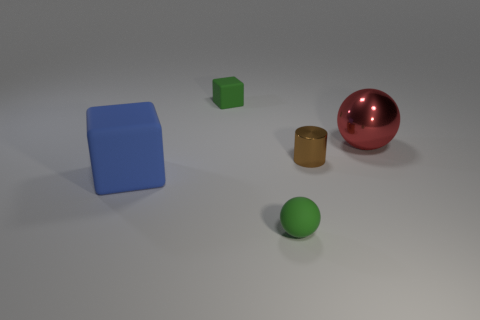There is a rubber thing behind the red sphere; does it have the same color as the tiny sphere?
Provide a succinct answer. Yes. Is the color of the tiny rubber ball the same as the object that is behind the large red shiny thing?
Ensure brevity in your answer.  Yes. Are there any other things that have the same color as the matte ball?
Make the answer very short. Yes. What material is the small green object that is the same shape as the big metallic thing?
Your answer should be very brief. Rubber. What shape is the tiny matte object that is the same color as the small rubber sphere?
Provide a succinct answer. Cube. There is another object that is made of the same material as the red object; what is its size?
Your answer should be compact. Small. Are there any brown cylinders left of the large shiny thing?
Make the answer very short. Yes. What is the size of the green thing in front of the tiny matte thing that is behind the sphere that is in front of the brown cylinder?
Provide a short and direct response. Small. What is the material of the tiny cube?
Provide a short and direct response. Rubber. There is a rubber block that is the same color as the tiny sphere; what size is it?
Provide a succinct answer. Small. 